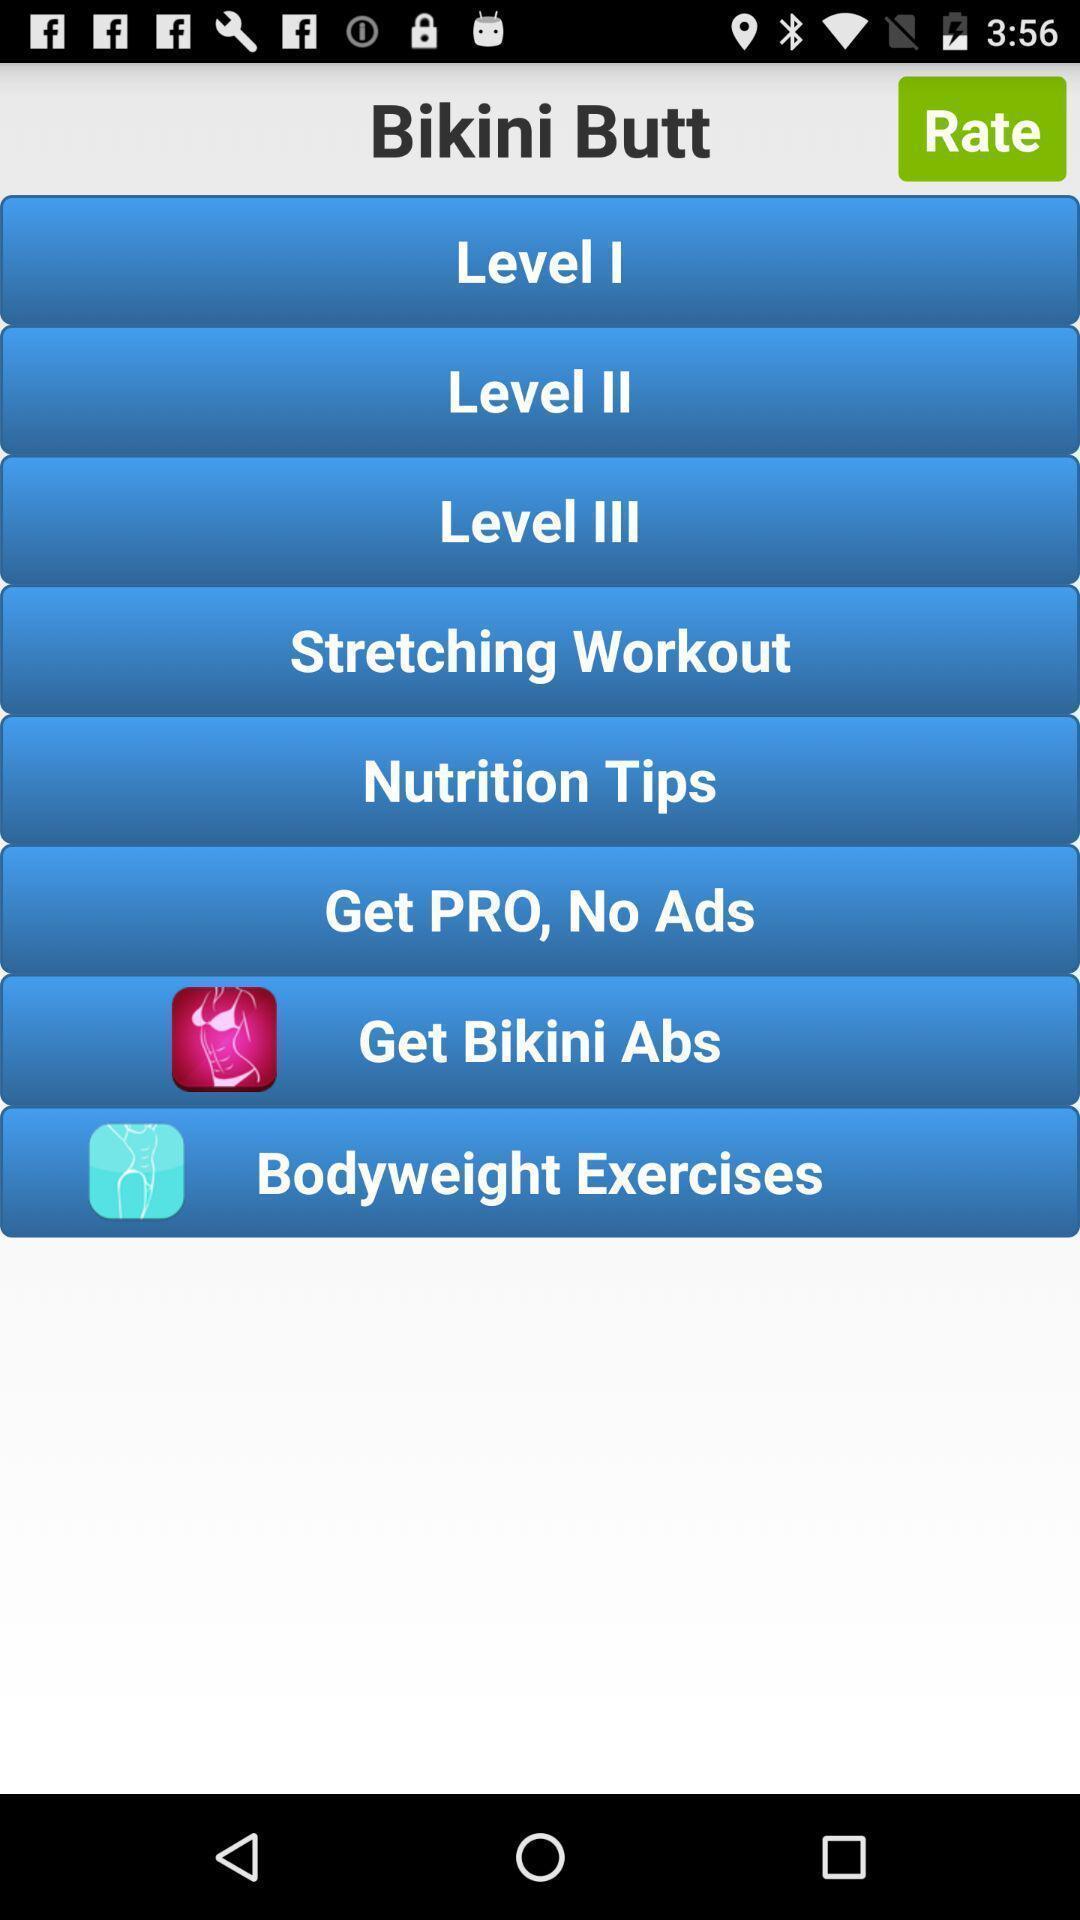Tell me about the visual elements in this screen capture. Page shows various levels of workout tips on fitness app. 